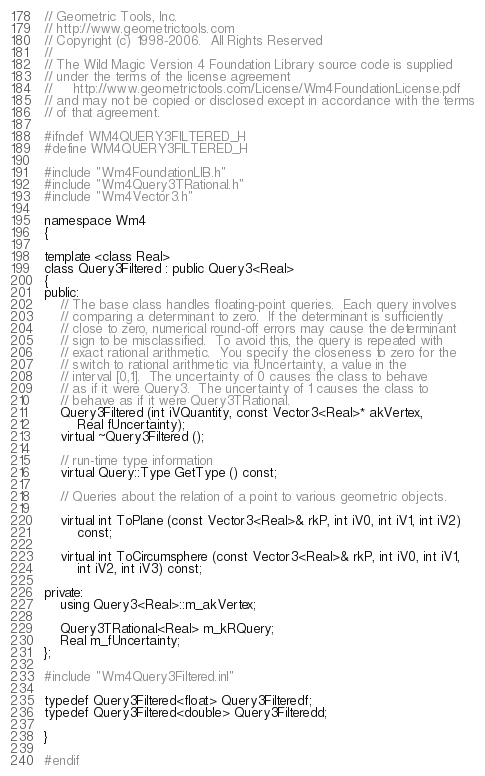<code> <loc_0><loc_0><loc_500><loc_500><_C_>// Geometric Tools, Inc.
// http://www.geometrictools.com
// Copyright (c) 1998-2006.  All Rights Reserved
//
// The Wild Magic Version 4 Foundation Library source code is supplied
// under the terms of the license agreement
//     http://www.geometrictools.com/License/Wm4FoundationLicense.pdf
// and may not be copied or disclosed except in accordance with the terms
// of that agreement.

#ifndef WM4QUERY3FILTERED_H
#define WM4QUERY3FILTERED_H

#include "Wm4FoundationLIB.h"
#include "Wm4Query3TRational.h"
#include "Wm4Vector3.h"

namespace Wm4
{

template <class Real>
class Query3Filtered : public Query3<Real>
{
public:
    // The base class handles floating-point queries.  Each query involves
    // comparing a determinant to zero.  If the determinant is sufficiently
    // close to zero, numerical round-off errors may cause the determinant
    // sign to be misclassified.  To avoid this, the query is repeated with
    // exact rational arithmetic.  You specify the closeness to zero for the
    // switch to rational arithmetic via fUncertainty, a value in the
    // interval [0,1].  The uncertainty of 0 causes the class to behave
    // as if it were Query3.  The uncertainty of 1 causes the class to
    // behave as if it were Query3TRational.
    Query3Filtered (int iVQuantity, const Vector3<Real>* akVertex,
        Real fUncertainty);
    virtual ~Query3Filtered ();

    // run-time type information
    virtual Query::Type GetType () const;

    // Queries about the relation of a point to various geometric objects.

    virtual int ToPlane (const Vector3<Real>& rkP, int iV0, int iV1, int iV2)
        const;

    virtual int ToCircumsphere (const Vector3<Real>& rkP, int iV0, int iV1,
        int iV2, int iV3) const;

private:
    using Query3<Real>::m_akVertex;

    Query3TRational<Real> m_kRQuery;
    Real m_fUncertainty;
};

#include "Wm4Query3Filtered.inl"

typedef Query3Filtered<float> Query3Filteredf;
typedef Query3Filtered<double> Query3Filteredd;

}

#endif
</code> 